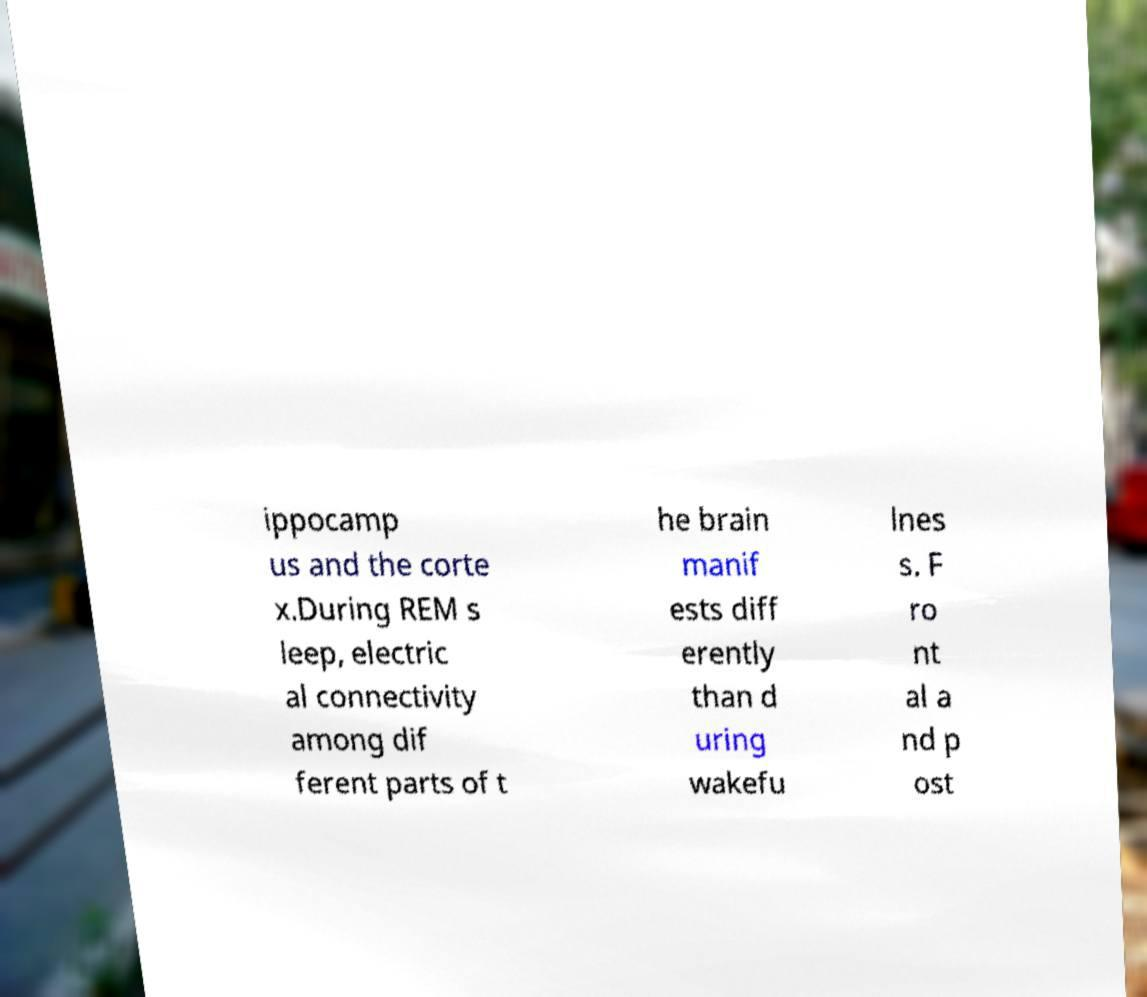There's text embedded in this image that I need extracted. Can you transcribe it verbatim? ippocamp us and the corte x.During REM s leep, electric al connectivity among dif ferent parts of t he brain manif ests diff erently than d uring wakefu lnes s. F ro nt al a nd p ost 